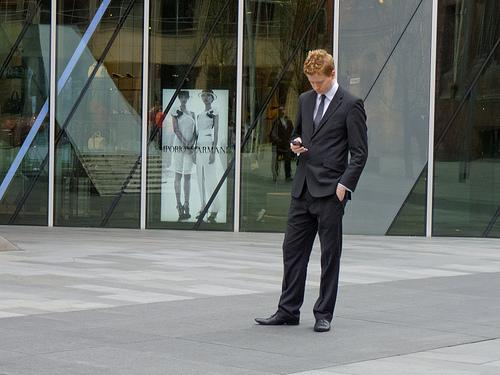What is the overall feeling or sentiment of this image? The image gives a sense of a busy urban street scene, with the man absorbed in his cell phone amidst a backdrop of shop windows and advertisements. Explain the task of determining the number of people present in the image and their actions. In the image, there is one person who is a man standing on the sidewalk and looking at his cell phone, and the reflection of another person can be seen in the window. Evaluate the quality of the image in terms of the clarity of the objects and subjects captured. The image is of good quality, as the objects and subjects are visible, with clear details such as the man's red hair, the clothing he is wearing, and the advertisement in the window. Count the number of ads and posters visible in the image. There are three ads or posters visible: Emporio Armani advertisement, fashion poster, and poster featuring two women. Determine the key features of the man's appearance that stand out in the image. The man has short red hair, is wearing a black suit with a black tie, white shirt, and black dress shoes, and he is holding a cell phone in his hand. Analyze the interaction between the man and his surroundings in the image. The man is focused on his cell phone, seemingly unaware and not interacting with his surroundings, like the Emporio Armani advertisement or the reflections in the window. Provide a brief summary of the most important details in the image. A red-haired man dressed in a black suit is standing on the sidewalk and looking at his cell phone, with an Emporio Armani advertisement in a nearby window. Deduce the purpose or scene of the image and what it might convey to viewers. The purpose of the image is to showcase the man in a busy urban setting, engaged with his phone, perhaps exemplifying modern reliance on technology or a moment in daily life. 